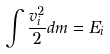Convert formula to latex. <formula><loc_0><loc_0><loc_500><loc_500>\int \frac { v _ { i } ^ { 2 } } { 2 } d m = E _ { i }</formula> 